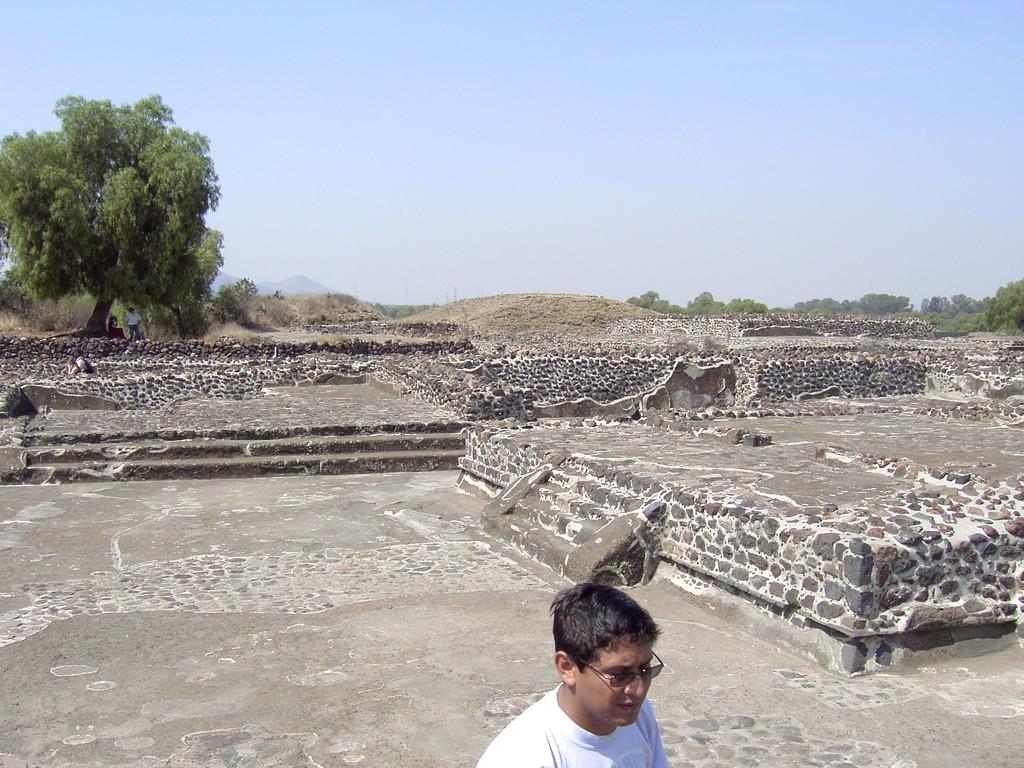Who or what is the main subject of the image? There is a person in the image. What is the person wearing? The person is wearing a white t-shirt. What can be seen in the background of the image? There are trees in the background of the image. What is visible at the top of the image? The sky is visible at the top of the image. What type of paste is being used by the person in the image? There is no paste visible in the image, and the person's actions are not described. 